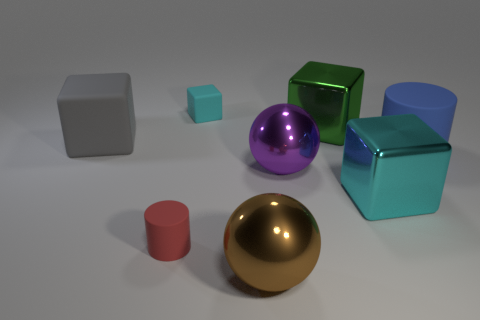Subtract all gray cylinders. How many cyan blocks are left? 2 Subtract all tiny matte cubes. How many cubes are left? 3 Subtract all green blocks. How many blocks are left? 3 Add 1 green cubes. How many objects exist? 9 Subtract all gray blocks. Subtract all cyan cylinders. How many blocks are left? 3 Subtract all balls. How many objects are left? 6 Subtract 0 yellow cylinders. How many objects are left? 8 Subtract all small purple metal things. Subtract all purple metal spheres. How many objects are left? 7 Add 4 purple spheres. How many purple spheres are left? 5 Add 2 metal blocks. How many metal blocks exist? 4 